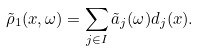Convert formula to latex. <formula><loc_0><loc_0><loc_500><loc_500>\tilde { \rho } _ { 1 } ( x , \omega ) = \sum _ { j \in I } \tilde { a } _ { j } ( \omega ) d _ { j } ( x ) .</formula> 